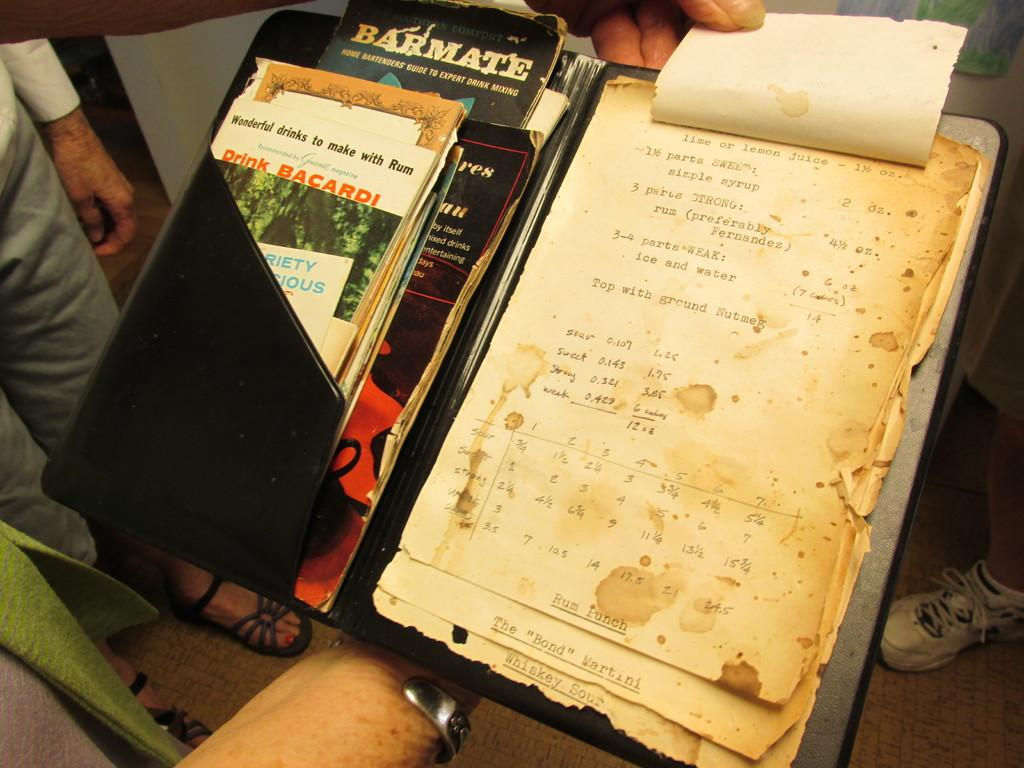<image>
Present a compact description of the photo's key features. books next to a stack of papers that one is titled 'barmate' 